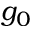Convert formula to latex. <formula><loc_0><loc_0><loc_500><loc_500>g _ { 0 }</formula> 